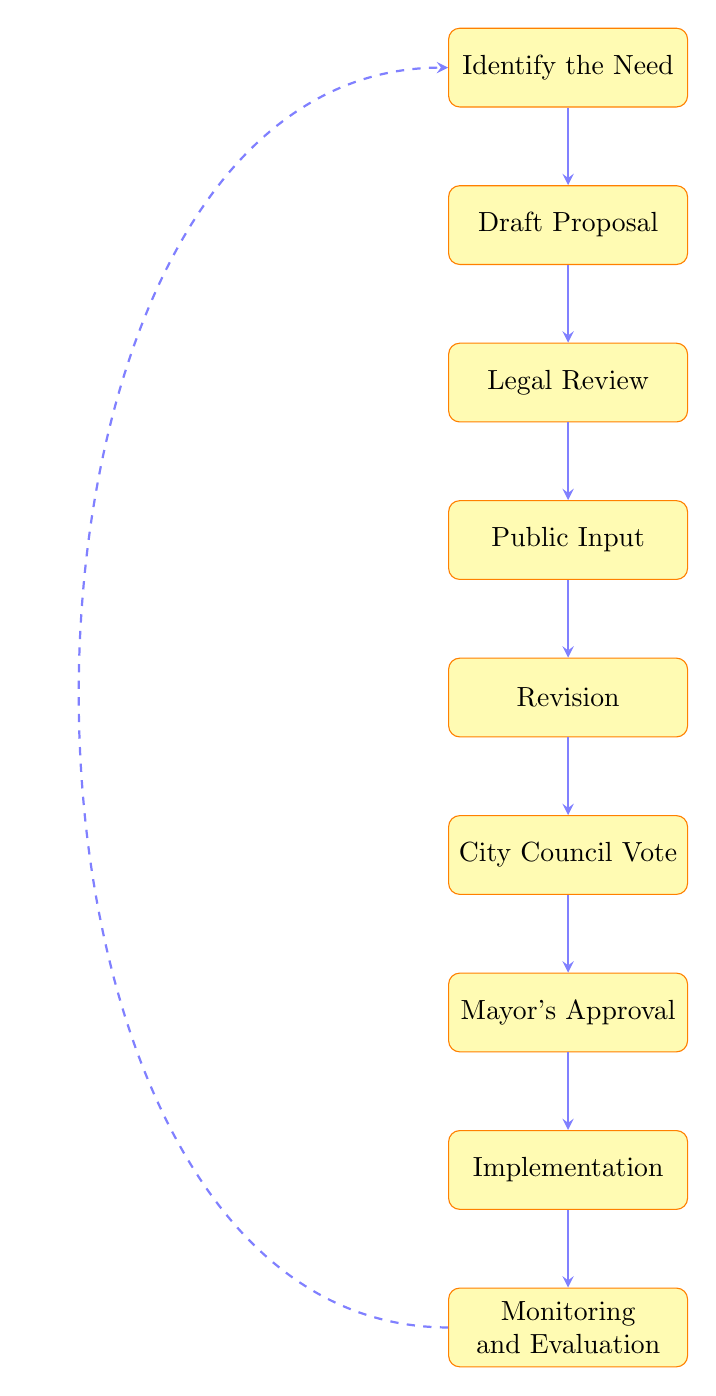What is the first step in implementing a new municipal ordinance? The initial step listed in the diagram is "Identify the Need," which signifies recognizing an issue or opportunity for a new ordinance.
Answer: Identify the Need How many total steps are there in the process? By counting each box in the flow chart from "Identify the Need" to "Monitoring and Evaluation," there are a total of nine steps depicted in the diagram.
Answer: Nine What step follows the "Draft Proposal"? Referring to the flow of the diagram, the step that comes after "Draft Proposal" is "Legal Review."
Answer: Legal Review What is the final step in the ordinance implementation process? The last step shown in the diagram is "Monitoring and Evaluation," which is crucial for assessing the ordinance's impact.
Answer: Monitoring and Evaluation What step requires input from the community? The "Public Input" step specifically involves gathering feedback and suggestions from residents, as indicated in the diagram.
Answer: Public Input Which step involves a decision from the mayor? In the flow chart, after the city council vote, the step that involves a decision from the mayor is "Mayor's Approval."
Answer: Mayor's Approval What happens after the "Mayor's Approval"? The next step following "Mayor's Approval" in the flow chart is "Implementation," which means city departments will enforce the new ordinance.
Answer: Implementation Which two steps involve revisions based on feedback? The two steps in the diagram that involve revisions based on feedback are "Revision" and "Legal Review," which indicate adjustments based on public and legal input.
Answer: Revision and Legal Review What action occurs immediately after "City Council Vote"? According to the diagram, the action that occurs immediately after "City Council Vote" is "Mayor's Approval," where the ordinance is sent for final approval.
Answer: Mayor's Approval 